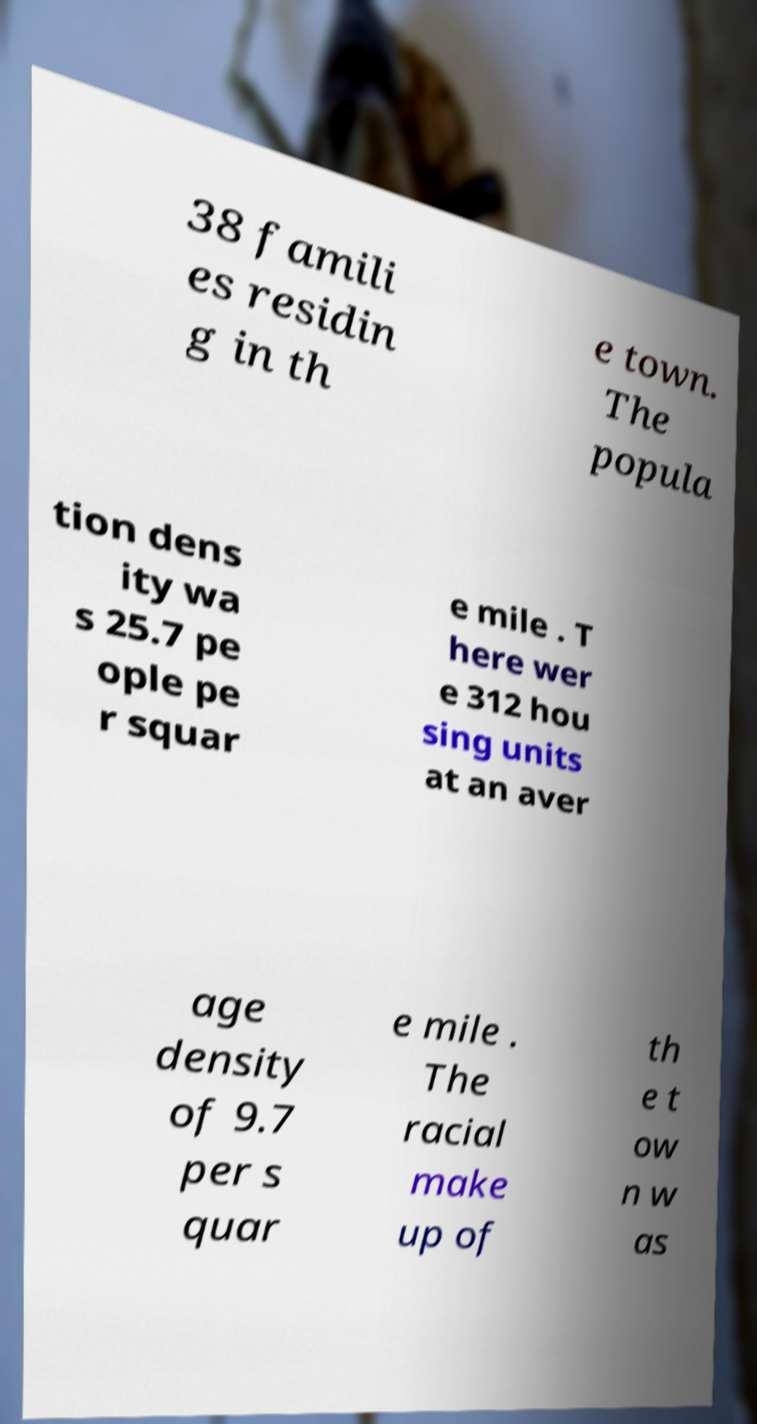I need the written content from this picture converted into text. Can you do that? 38 famili es residin g in th e town. The popula tion dens ity wa s 25.7 pe ople pe r squar e mile . T here wer e 312 hou sing units at an aver age density of 9.7 per s quar e mile . The racial make up of th e t ow n w as 